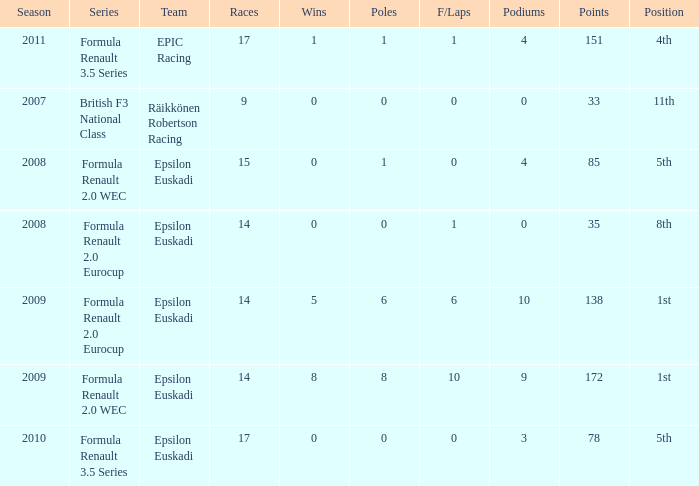What team was he on when he finished in 11th position? Räikkönen Robertson Racing. 